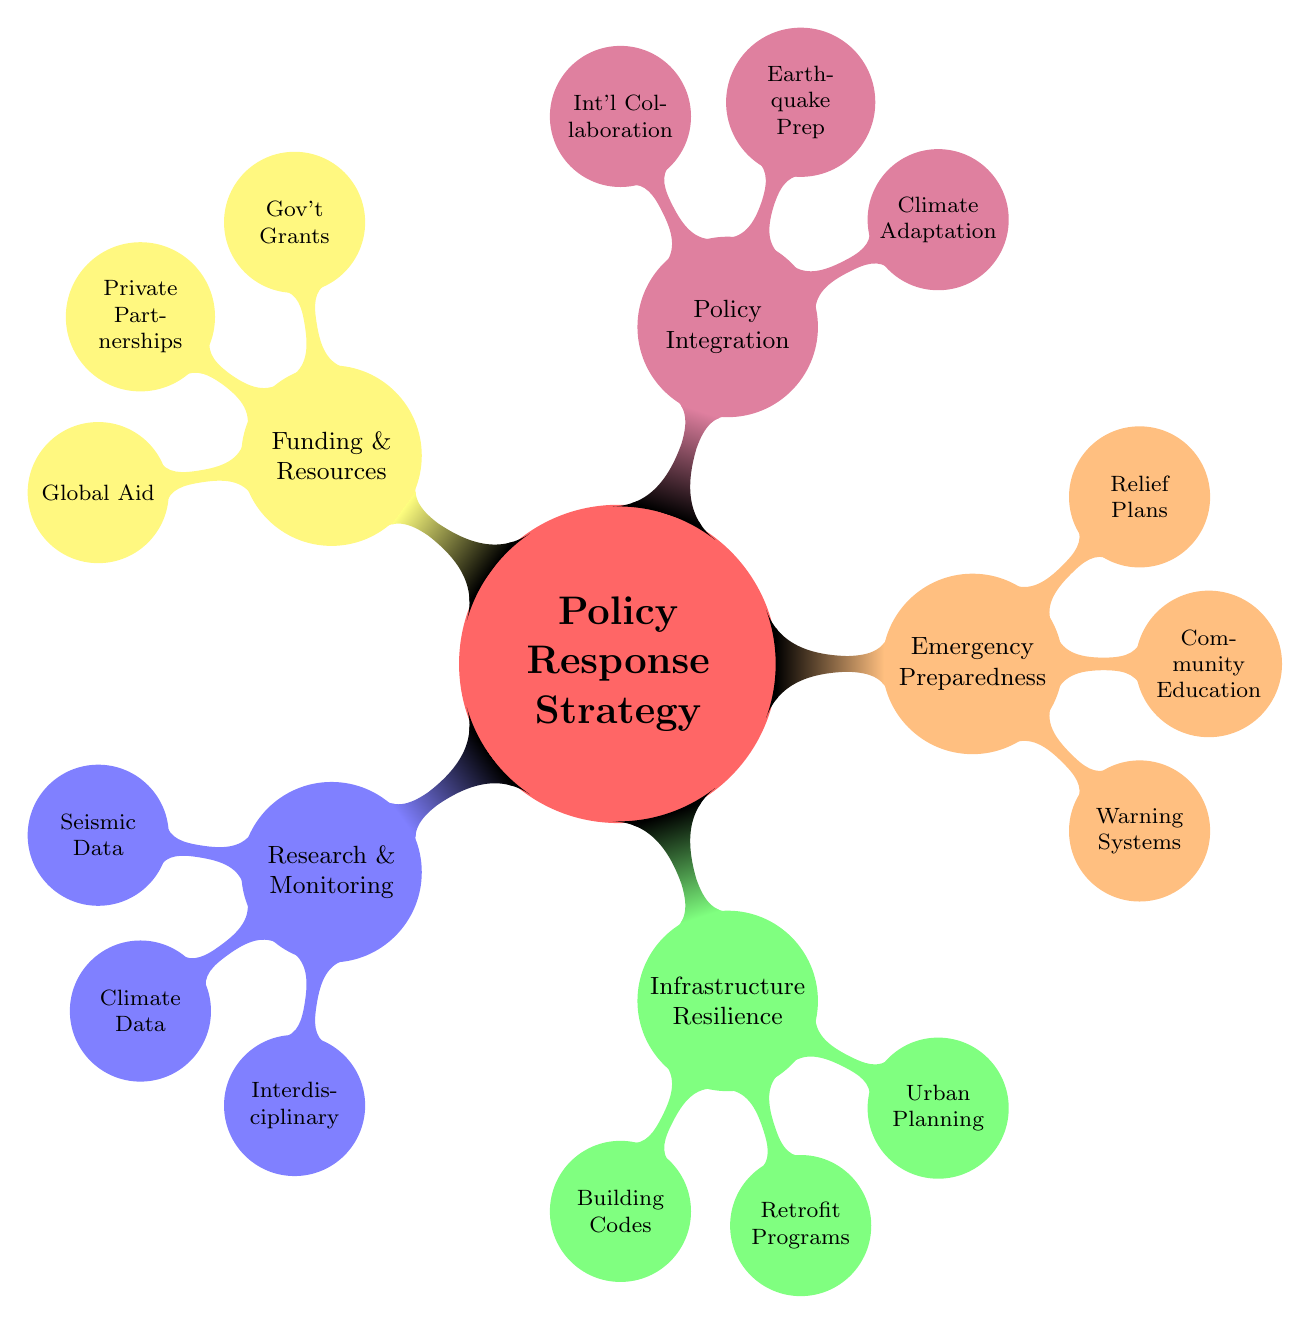What are the main areas of focus in the policy response strategy? The main areas are Research and Monitoring, Infrastructure Resilience, Emergency Preparedness, Policy Integration, and Funding and Resources. Each area is a primary category represented in the mind map.
Answer: Research and Monitoring, Infrastructure Resilience, Emergency Preparedness, Policy Integration, Funding and Resources How many subcategories are under 'Emergency Preparedness'? 'Emergency Preparedness' has three subcategories: Early Warning Systems, Community Education, and Rescue and Relief Plans. This is evident from the nodes branching from the 'Emergency Preparedness' node.
Answer: 3 What organization is associated with ‘Building Codes’? The node under 'Building Codes' points to the International Building Code (IBC), which is indicated as the organization responsible for building codes in the context of the diagram.
Answer: International Building Code (IBC) Which areas are associated with funding in the response strategy? The Funding and Resources category has three subcategories: Government Grants, Private Sector Partnerships, and Global Aid Programs. This means funding is spread across these three areas as depicted in the mind map.
Answer: Government Grants, Private Sector Partnerships, Global Aid Programs What type of policies is integrated with Climate Adaptation Plans? Climate Adaptation Plans are integrated with Earthquake Preparedness Policies as indicated by their position within the Policy Integration node in the diagram.
Answer: Earthquake Preparedness Policies What is the focus of the Climate Data Collection node? The Climate Data Collection node is associated with NASA Earth Science Division, which indicates its focus on climate data at a national and global levels.
Answer: NASA Earth Science Division How do the nodes in the diagram relate to one another? The nodes relate in a hierarchical structure where the main idea is 'Policy Response Strategy', and each category branches into subcategories showing specific strategies or organizations connected to that main idea. This illustrates a clear logical progression from general policy to specific actions or entities.
Answer: Hierarchical structure Which program is linked to Community Education? The Community Education node explicitly points to Red Cross Preparedness Programs, making this the program linked to the education aspect in the emergency preparedness category.
Answer: Red Cross Preparedness Programs 